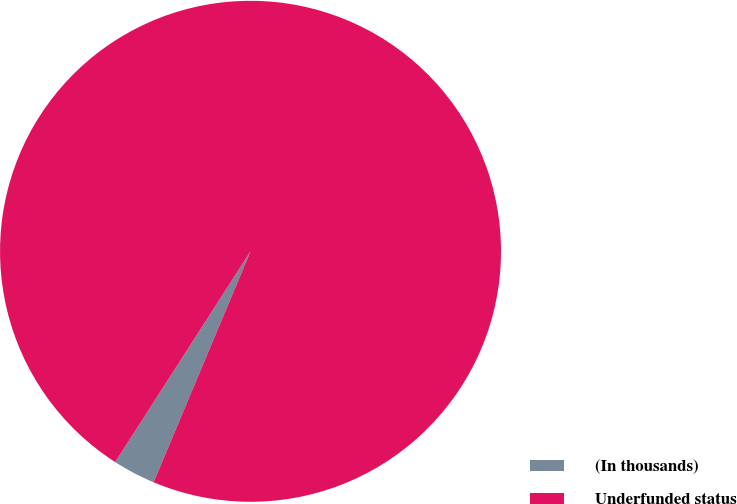Convert chart. <chart><loc_0><loc_0><loc_500><loc_500><pie_chart><fcel>(In thousands)<fcel>Underfunded status<nl><fcel>2.76%<fcel>97.24%<nl></chart> 